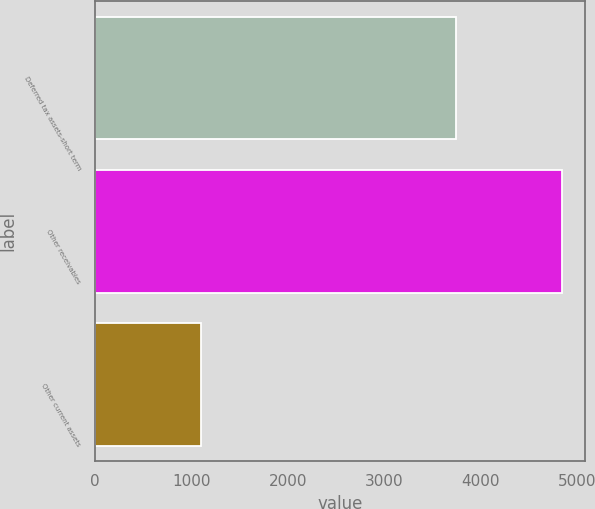<chart> <loc_0><loc_0><loc_500><loc_500><bar_chart><fcel>Deferred tax assets-short term<fcel>Other receivables<fcel>Other current assets<nl><fcel>3744<fcel>4839<fcel>1102<nl></chart> 